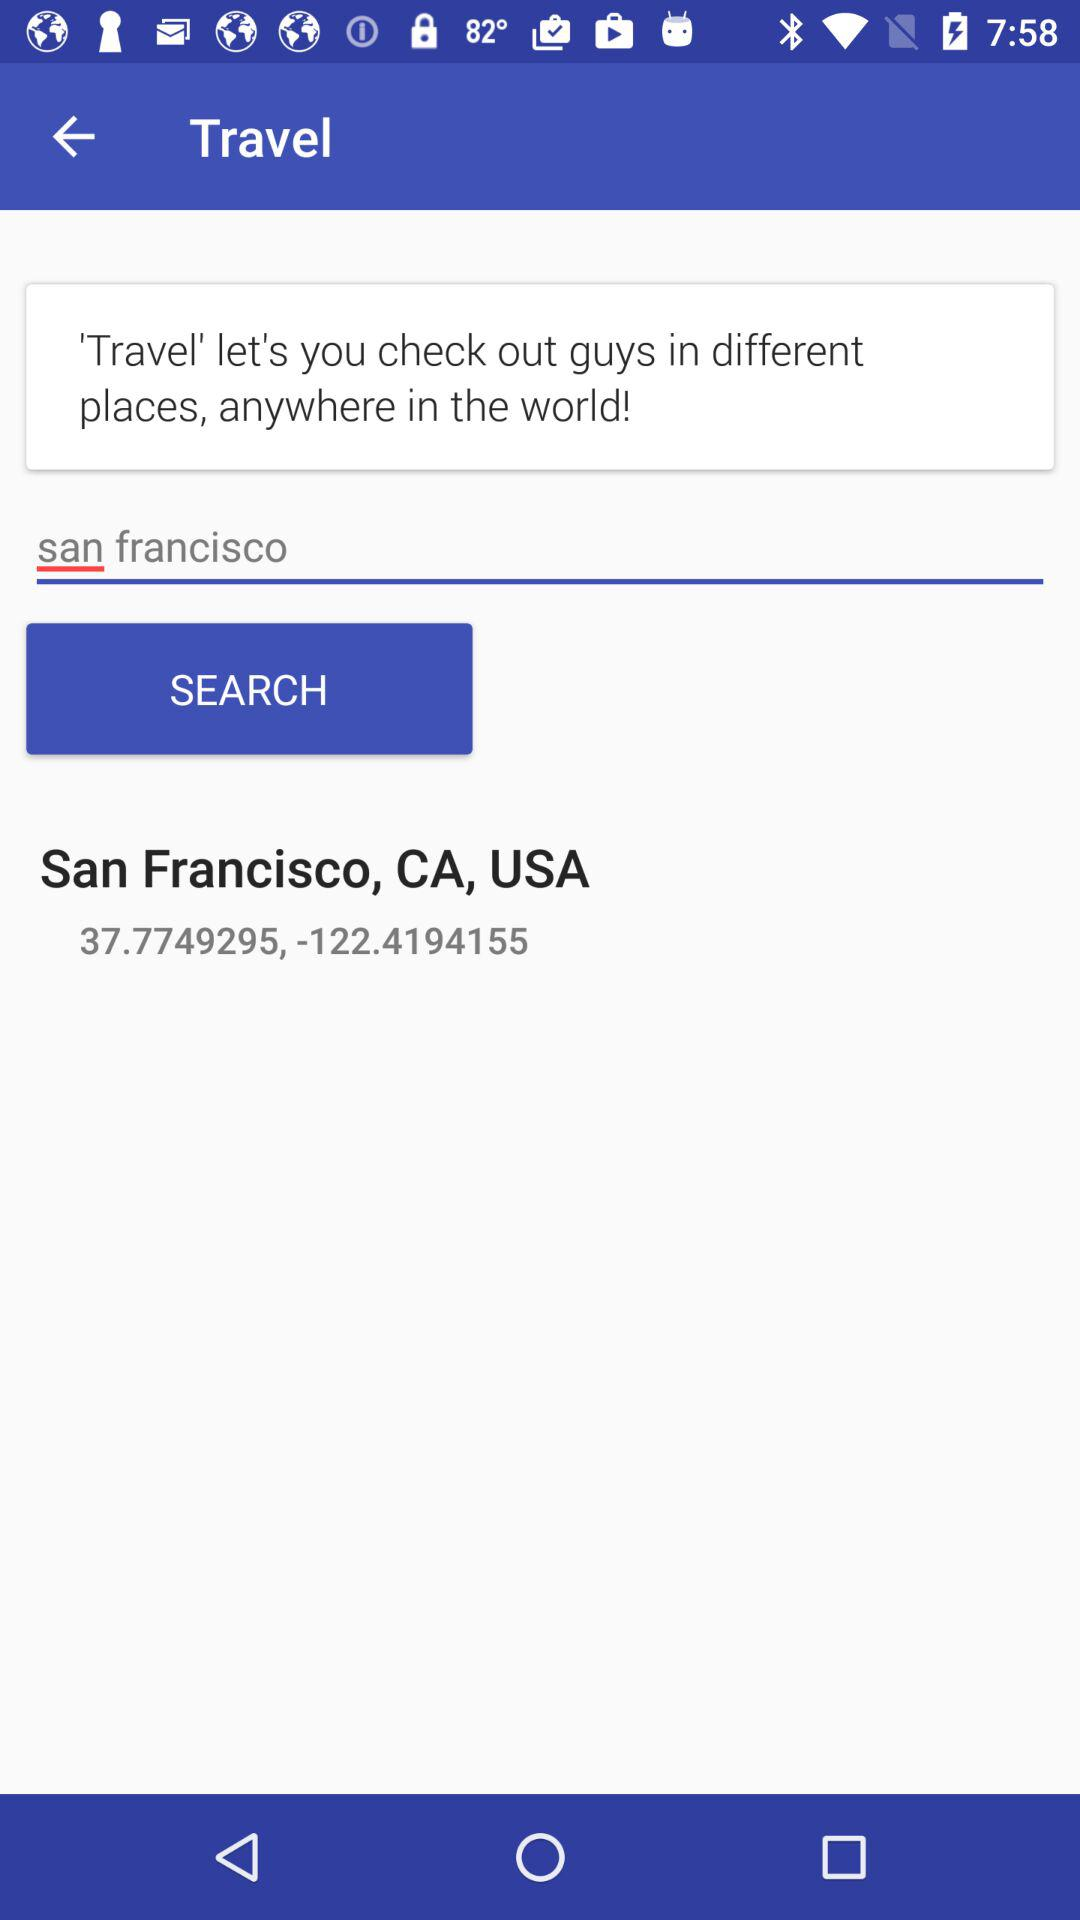What is the latitude of the location that is being searched for?
Answer the question using a single word or phrase. 37.779295 